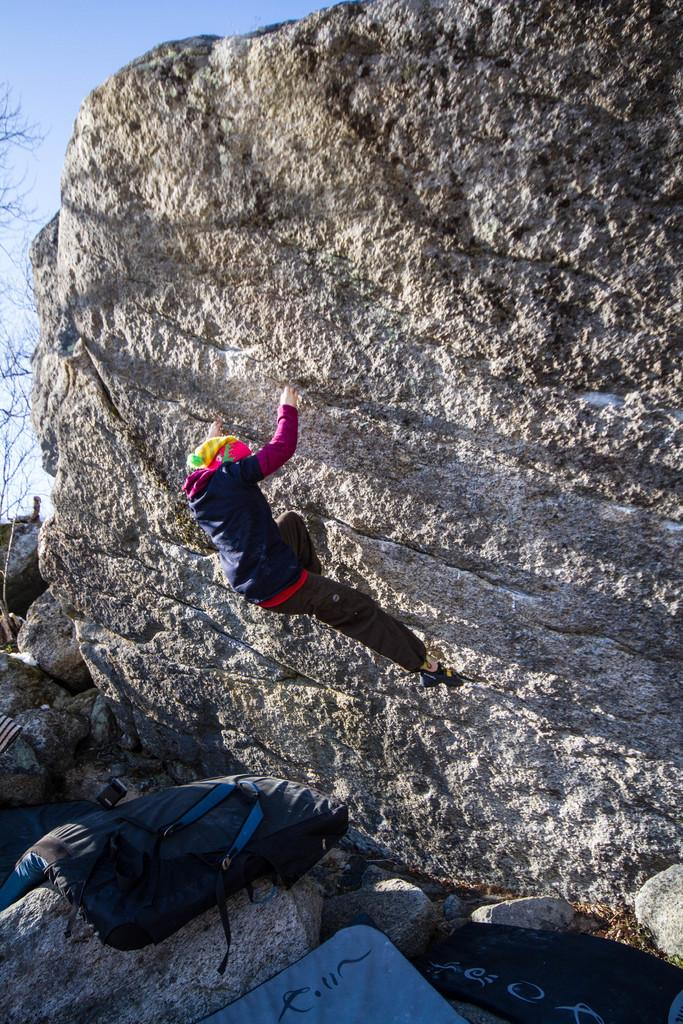What is the main activity being performed in the image? There is a person climbing a rock in the image. What can be seen at the bottom of the rock? There are bags on the rocks at the bottom of the image. What is visible on the left side of the image? There are branches on the left side of the image. What is visible in the background of the image? The sky is visible in the image. How many mittens can be seen on the person climbing the rock in the image? There are no mittens visible in the image; the person is not wearing any. 